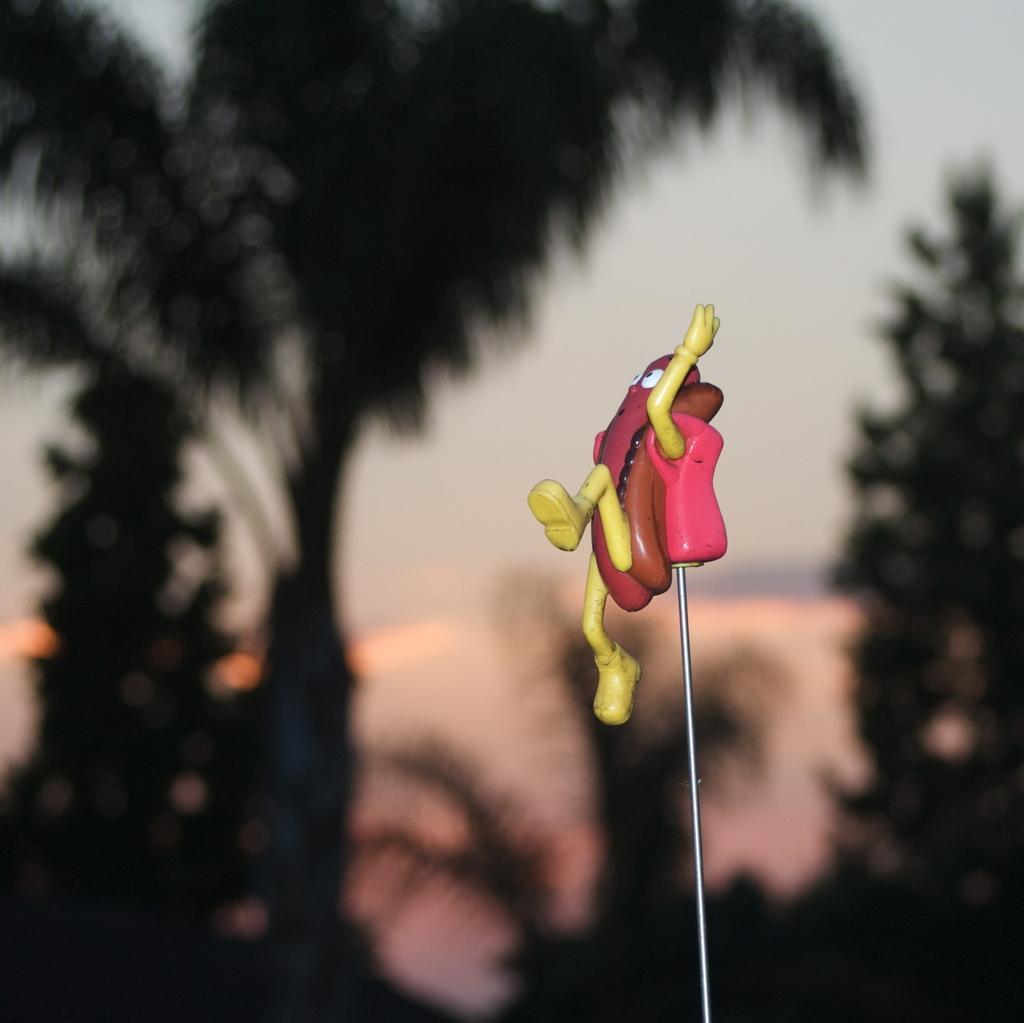How would you summarize this image in a sentence or two? As we can see in the image in the front there is a toy. In the background there are trees and sky. The background is blurred. 